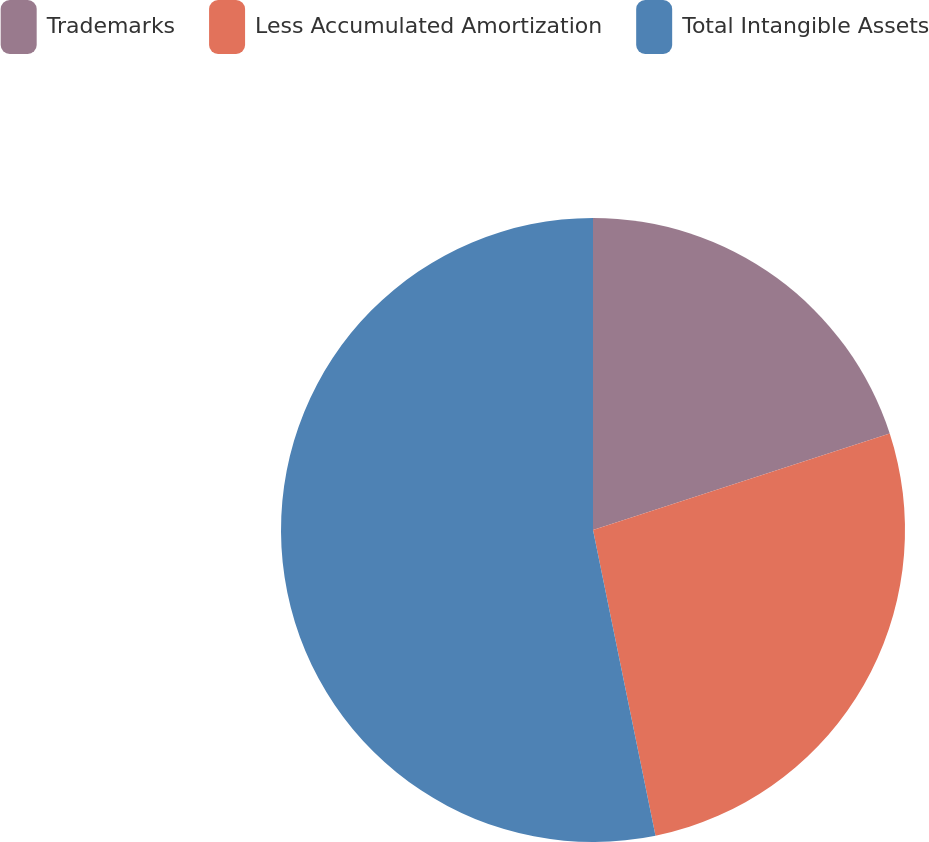Convert chart to OTSL. <chart><loc_0><loc_0><loc_500><loc_500><pie_chart><fcel>Trademarks<fcel>Less Accumulated Amortization<fcel>Total Intangible Assets<nl><fcel>20.0%<fcel>26.79%<fcel>53.21%<nl></chart> 